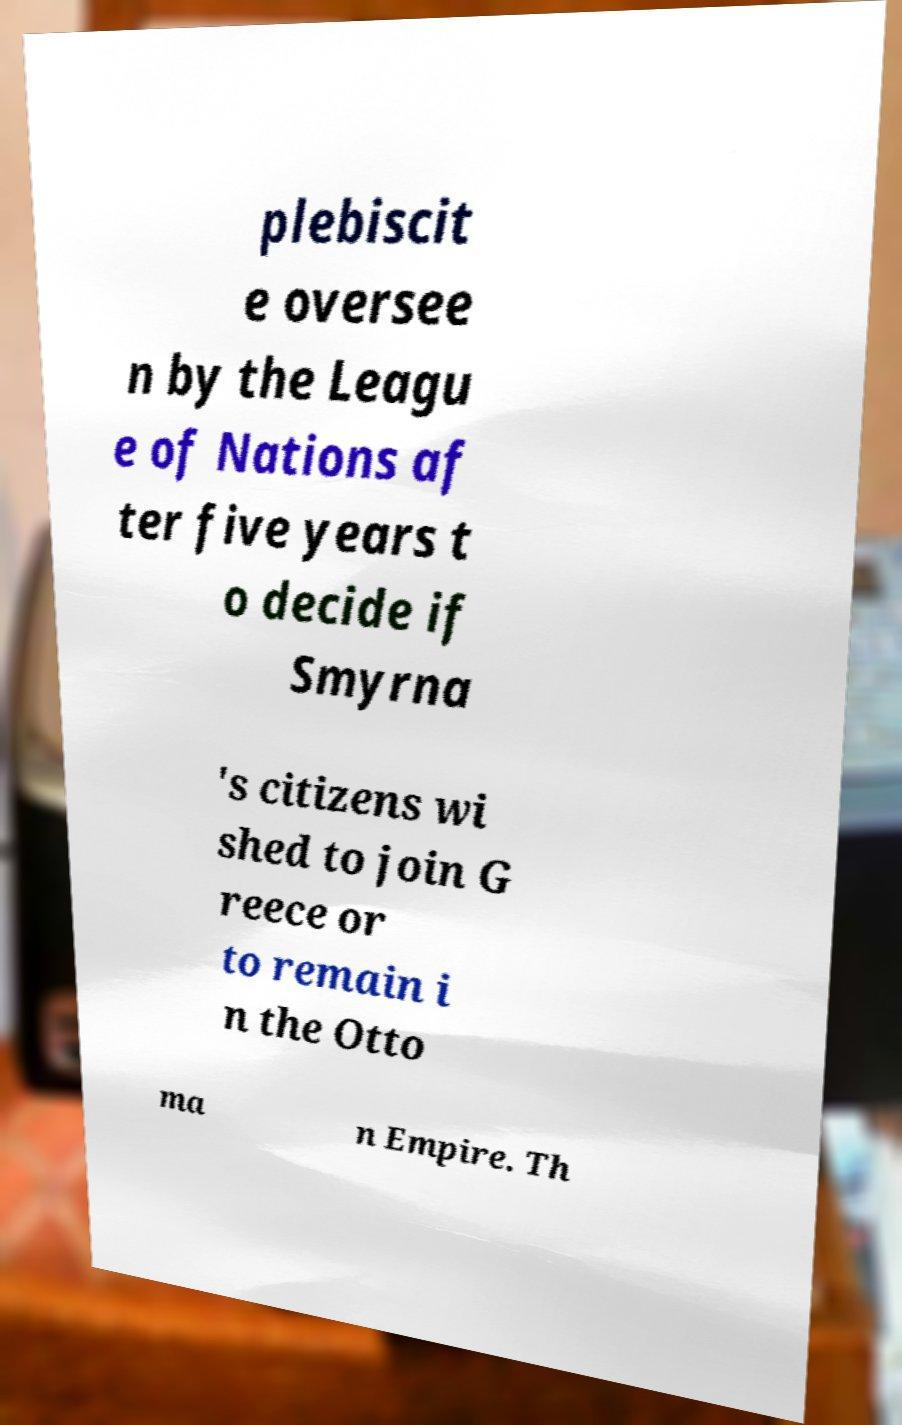For documentation purposes, I need the text within this image transcribed. Could you provide that? plebiscit e oversee n by the Leagu e of Nations af ter five years t o decide if Smyrna 's citizens wi shed to join G reece or to remain i n the Otto ma n Empire. Th 